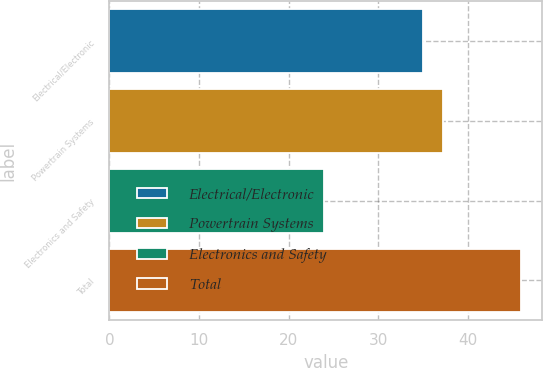Convert chart. <chart><loc_0><loc_0><loc_500><loc_500><bar_chart><fcel>Electrical/Electronic<fcel>Powertrain Systems<fcel>Electronics and Safety<fcel>Total<nl><fcel>35<fcel>37.2<fcel>24<fcel>46<nl></chart> 